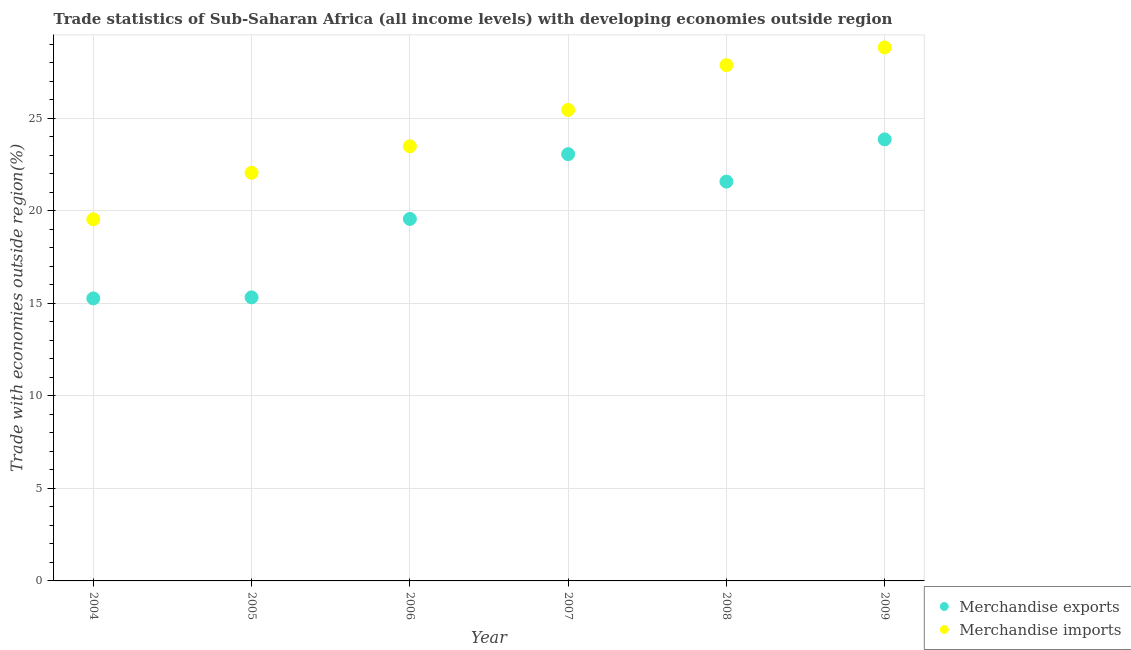How many different coloured dotlines are there?
Provide a succinct answer. 2. Is the number of dotlines equal to the number of legend labels?
Provide a short and direct response. Yes. What is the merchandise exports in 2006?
Offer a terse response. 19.56. Across all years, what is the maximum merchandise imports?
Your response must be concise. 28.83. Across all years, what is the minimum merchandise imports?
Keep it short and to the point. 19.54. In which year was the merchandise exports maximum?
Ensure brevity in your answer.  2009. In which year was the merchandise exports minimum?
Your answer should be compact. 2004. What is the total merchandise exports in the graph?
Make the answer very short. 118.64. What is the difference between the merchandise imports in 2006 and that in 2009?
Your answer should be very brief. -5.34. What is the difference between the merchandise exports in 2006 and the merchandise imports in 2008?
Offer a terse response. -8.31. What is the average merchandise imports per year?
Your response must be concise. 24.54. In the year 2008, what is the difference between the merchandise imports and merchandise exports?
Your response must be concise. 6.29. In how many years, is the merchandise imports greater than 22 %?
Offer a terse response. 5. What is the ratio of the merchandise exports in 2006 to that in 2009?
Provide a short and direct response. 0.82. Is the merchandise imports in 2004 less than that in 2005?
Your response must be concise. Yes. Is the difference between the merchandise exports in 2005 and 2009 greater than the difference between the merchandise imports in 2005 and 2009?
Provide a succinct answer. No. What is the difference between the highest and the second highest merchandise exports?
Provide a short and direct response. 0.8. What is the difference between the highest and the lowest merchandise imports?
Offer a very short reply. 9.28. In how many years, is the merchandise imports greater than the average merchandise imports taken over all years?
Keep it short and to the point. 3. Is the sum of the merchandise exports in 2008 and 2009 greater than the maximum merchandise imports across all years?
Make the answer very short. Yes. Is the merchandise exports strictly greater than the merchandise imports over the years?
Provide a short and direct response. No. How many dotlines are there?
Offer a terse response. 2. Does the graph contain grids?
Your answer should be compact. Yes. How many legend labels are there?
Offer a very short reply. 2. What is the title of the graph?
Keep it short and to the point. Trade statistics of Sub-Saharan Africa (all income levels) with developing economies outside region. Does "Merchandise imports" appear as one of the legend labels in the graph?
Ensure brevity in your answer.  Yes. What is the label or title of the Y-axis?
Keep it short and to the point. Trade with economies outside region(%). What is the Trade with economies outside region(%) in Merchandise exports in 2004?
Offer a very short reply. 15.27. What is the Trade with economies outside region(%) of Merchandise imports in 2004?
Your response must be concise. 19.54. What is the Trade with economies outside region(%) in Merchandise exports in 2005?
Provide a succinct answer. 15.32. What is the Trade with economies outside region(%) of Merchandise imports in 2005?
Offer a very short reply. 22.05. What is the Trade with economies outside region(%) of Merchandise exports in 2006?
Provide a succinct answer. 19.56. What is the Trade with economies outside region(%) in Merchandise imports in 2006?
Provide a succinct answer. 23.48. What is the Trade with economies outside region(%) of Merchandise exports in 2007?
Give a very brief answer. 23.06. What is the Trade with economies outside region(%) of Merchandise imports in 2007?
Offer a very short reply. 25.45. What is the Trade with economies outside region(%) of Merchandise exports in 2008?
Give a very brief answer. 21.58. What is the Trade with economies outside region(%) in Merchandise imports in 2008?
Offer a very short reply. 27.87. What is the Trade with economies outside region(%) of Merchandise exports in 2009?
Give a very brief answer. 23.86. What is the Trade with economies outside region(%) of Merchandise imports in 2009?
Offer a very short reply. 28.83. Across all years, what is the maximum Trade with economies outside region(%) in Merchandise exports?
Make the answer very short. 23.86. Across all years, what is the maximum Trade with economies outside region(%) in Merchandise imports?
Offer a terse response. 28.83. Across all years, what is the minimum Trade with economies outside region(%) of Merchandise exports?
Keep it short and to the point. 15.27. Across all years, what is the minimum Trade with economies outside region(%) of Merchandise imports?
Ensure brevity in your answer.  19.54. What is the total Trade with economies outside region(%) of Merchandise exports in the graph?
Your answer should be compact. 118.64. What is the total Trade with economies outside region(%) of Merchandise imports in the graph?
Offer a terse response. 147.22. What is the difference between the Trade with economies outside region(%) in Merchandise exports in 2004 and that in 2005?
Your answer should be very brief. -0.06. What is the difference between the Trade with economies outside region(%) of Merchandise imports in 2004 and that in 2005?
Provide a succinct answer. -2.51. What is the difference between the Trade with economies outside region(%) of Merchandise exports in 2004 and that in 2006?
Ensure brevity in your answer.  -4.29. What is the difference between the Trade with economies outside region(%) in Merchandise imports in 2004 and that in 2006?
Provide a succinct answer. -3.94. What is the difference between the Trade with economies outside region(%) of Merchandise exports in 2004 and that in 2007?
Your answer should be compact. -7.79. What is the difference between the Trade with economies outside region(%) of Merchandise imports in 2004 and that in 2007?
Offer a very short reply. -5.91. What is the difference between the Trade with economies outside region(%) in Merchandise exports in 2004 and that in 2008?
Provide a short and direct response. -6.31. What is the difference between the Trade with economies outside region(%) of Merchandise imports in 2004 and that in 2008?
Give a very brief answer. -8.33. What is the difference between the Trade with economies outside region(%) of Merchandise exports in 2004 and that in 2009?
Keep it short and to the point. -8.59. What is the difference between the Trade with economies outside region(%) of Merchandise imports in 2004 and that in 2009?
Offer a terse response. -9.29. What is the difference between the Trade with economies outside region(%) of Merchandise exports in 2005 and that in 2006?
Keep it short and to the point. -4.24. What is the difference between the Trade with economies outside region(%) in Merchandise imports in 2005 and that in 2006?
Your answer should be compact. -1.43. What is the difference between the Trade with economies outside region(%) in Merchandise exports in 2005 and that in 2007?
Make the answer very short. -7.74. What is the difference between the Trade with economies outside region(%) of Merchandise imports in 2005 and that in 2007?
Provide a short and direct response. -3.4. What is the difference between the Trade with economies outside region(%) of Merchandise exports in 2005 and that in 2008?
Provide a short and direct response. -6.25. What is the difference between the Trade with economies outside region(%) in Merchandise imports in 2005 and that in 2008?
Give a very brief answer. -5.82. What is the difference between the Trade with economies outside region(%) in Merchandise exports in 2005 and that in 2009?
Keep it short and to the point. -8.54. What is the difference between the Trade with economies outside region(%) of Merchandise imports in 2005 and that in 2009?
Your answer should be very brief. -6.77. What is the difference between the Trade with economies outside region(%) in Merchandise exports in 2006 and that in 2007?
Your answer should be compact. -3.5. What is the difference between the Trade with economies outside region(%) of Merchandise imports in 2006 and that in 2007?
Provide a short and direct response. -1.97. What is the difference between the Trade with economies outside region(%) in Merchandise exports in 2006 and that in 2008?
Provide a short and direct response. -2.02. What is the difference between the Trade with economies outside region(%) of Merchandise imports in 2006 and that in 2008?
Make the answer very short. -4.39. What is the difference between the Trade with economies outside region(%) in Merchandise exports in 2006 and that in 2009?
Ensure brevity in your answer.  -4.3. What is the difference between the Trade with economies outside region(%) of Merchandise imports in 2006 and that in 2009?
Give a very brief answer. -5.34. What is the difference between the Trade with economies outside region(%) in Merchandise exports in 2007 and that in 2008?
Offer a very short reply. 1.48. What is the difference between the Trade with economies outside region(%) in Merchandise imports in 2007 and that in 2008?
Provide a succinct answer. -2.42. What is the difference between the Trade with economies outside region(%) of Merchandise exports in 2007 and that in 2009?
Your response must be concise. -0.8. What is the difference between the Trade with economies outside region(%) of Merchandise imports in 2007 and that in 2009?
Keep it short and to the point. -3.38. What is the difference between the Trade with economies outside region(%) of Merchandise exports in 2008 and that in 2009?
Ensure brevity in your answer.  -2.28. What is the difference between the Trade with economies outside region(%) in Merchandise imports in 2008 and that in 2009?
Provide a succinct answer. -0.96. What is the difference between the Trade with economies outside region(%) of Merchandise exports in 2004 and the Trade with economies outside region(%) of Merchandise imports in 2005?
Ensure brevity in your answer.  -6.79. What is the difference between the Trade with economies outside region(%) in Merchandise exports in 2004 and the Trade with economies outside region(%) in Merchandise imports in 2006?
Ensure brevity in your answer.  -8.22. What is the difference between the Trade with economies outside region(%) in Merchandise exports in 2004 and the Trade with economies outside region(%) in Merchandise imports in 2007?
Your response must be concise. -10.18. What is the difference between the Trade with economies outside region(%) of Merchandise exports in 2004 and the Trade with economies outside region(%) of Merchandise imports in 2008?
Your answer should be very brief. -12.6. What is the difference between the Trade with economies outside region(%) of Merchandise exports in 2004 and the Trade with economies outside region(%) of Merchandise imports in 2009?
Offer a very short reply. -13.56. What is the difference between the Trade with economies outside region(%) of Merchandise exports in 2005 and the Trade with economies outside region(%) of Merchandise imports in 2006?
Keep it short and to the point. -8.16. What is the difference between the Trade with economies outside region(%) of Merchandise exports in 2005 and the Trade with economies outside region(%) of Merchandise imports in 2007?
Ensure brevity in your answer.  -10.13. What is the difference between the Trade with economies outside region(%) of Merchandise exports in 2005 and the Trade with economies outside region(%) of Merchandise imports in 2008?
Provide a short and direct response. -12.55. What is the difference between the Trade with economies outside region(%) of Merchandise exports in 2005 and the Trade with economies outside region(%) of Merchandise imports in 2009?
Keep it short and to the point. -13.5. What is the difference between the Trade with economies outside region(%) of Merchandise exports in 2006 and the Trade with economies outside region(%) of Merchandise imports in 2007?
Your response must be concise. -5.89. What is the difference between the Trade with economies outside region(%) in Merchandise exports in 2006 and the Trade with economies outside region(%) in Merchandise imports in 2008?
Make the answer very short. -8.31. What is the difference between the Trade with economies outside region(%) of Merchandise exports in 2006 and the Trade with economies outside region(%) of Merchandise imports in 2009?
Offer a terse response. -9.27. What is the difference between the Trade with economies outside region(%) of Merchandise exports in 2007 and the Trade with economies outside region(%) of Merchandise imports in 2008?
Give a very brief answer. -4.81. What is the difference between the Trade with economies outside region(%) in Merchandise exports in 2007 and the Trade with economies outside region(%) in Merchandise imports in 2009?
Your answer should be very brief. -5.77. What is the difference between the Trade with economies outside region(%) in Merchandise exports in 2008 and the Trade with economies outside region(%) in Merchandise imports in 2009?
Make the answer very short. -7.25. What is the average Trade with economies outside region(%) in Merchandise exports per year?
Offer a very short reply. 19.77. What is the average Trade with economies outside region(%) of Merchandise imports per year?
Ensure brevity in your answer.  24.54. In the year 2004, what is the difference between the Trade with economies outside region(%) of Merchandise exports and Trade with economies outside region(%) of Merchandise imports?
Provide a short and direct response. -4.28. In the year 2005, what is the difference between the Trade with economies outside region(%) in Merchandise exports and Trade with economies outside region(%) in Merchandise imports?
Your answer should be very brief. -6.73. In the year 2006, what is the difference between the Trade with economies outside region(%) in Merchandise exports and Trade with economies outside region(%) in Merchandise imports?
Your answer should be compact. -3.92. In the year 2007, what is the difference between the Trade with economies outside region(%) of Merchandise exports and Trade with economies outside region(%) of Merchandise imports?
Your response must be concise. -2.39. In the year 2008, what is the difference between the Trade with economies outside region(%) in Merchandise exports and Trade with economies outside region(%) in Merchandise imports?
Provide a succinct answer. -6.29. In the year 2009, what is the difference between the Trade with economies outside region(%) of Merchandise exports and Trade with economies outside region(%) of Merchandise imports?
Provide a succinct answer. -4.97. What is the ratio of the Trade with economies outside region(%) in Merchandise imports in 2004 to that in 2005?
Provide a short and direct response. 0.89. What is the ratio of the Trade with economies outside region(%) in Merchandise exports in 2004 to that in 2006?
Offer a very short reply. 0.78. What is the ratio of the Trade with economies outside region(%) of Merchandise imports in 2004 to that in 2006?
Give a very brief answer. 0.83. What is the ratio of the Trade with economies outside region(%) of Merchandise exports in 2004 to that in 2007?
Your answer should be compact. 0.66. What is the ratio of the Trade with economies outside region(%) in Merchandise imports in 2004 to that in 2007?
Your answer should be very brief. 0.77. What is the ratio of the Trade with economies outside region(%) of Merchandise exports in 2004 to that in 2008?
Keep it short and to the point. 0.71. What is the ratio of the Trade with economies outside region(%) of Merchandise imports in 2004 to that in 2008?
Your response must be concise. 0.7. What is the ratio of the Trade with economies outside region(%) of Merchandise exports in 2004 to that in 2009?
Provide a short and direct response. 0.64. What is the ratio of the Trade with economies outside region(%) in Merchandise imports in 2004 to that in 2009?
Make the answer very short. 0.68. What is the ratio of the Trade with economies outside region(%) in Merchandise exports in 2005 to that in 2006?
Ensure brevity in your answer.  0.78. What is the ratio of the Trade with economies outside region(%) of Merchandise imports in 2005 to that in 2006?
Give a very brief answer. 0.94. What is the ratio of the Trade with economies outside region(%) in Merchandise exports in 2005 to that in 2007?
Keep it short and to the point. 0.66. What is the ratio of the Trade with economies outside region(%) in Merchandise imports in 2005 to that in 2007?
Your answer should be compact. 0.87. What is the ratio of the Trade with economies outside region(%) in Merchandise exports in 2005 to that in 2008?
Provide a succinct answer. 0.71. What is the ratio of the Trade with economies outside region(%) of Merchandise imports in 2005 to that in 2008?
Ensure brevity in your answer.  0.79. What is the ratio of the Trade with economies outside region(%) of Merchandise exports in 2005 to that in 2009?
Your answer should be very brief. 0.64. What is the ratio of the Trade with economies outside region(%) in Merchandise imports in 2005 to that in 2009?
Give a very brief answer. 0.77. What is the ratio of the Trade with economies outside region(%) of Merchandise exports in 2006 to that in 2007?
Provide a succinct answer. 0.85. What is the ratio of the Trade with economies outside region(%) of Merchandise imports in 2006 to that in 2007?
Offer a terse response. 0.92. What is the ratio of the Trade with economies outside region(%) in Merchandise exports in 2006 to that in 2008?
Provide a succinct answer. 0.91. What is the ratio of the Trade with economies outside region(%) in Merchandise imports in 2006 to that in 2008?
Keep it short and to the point. 0.84. What is the ratio of the Trade with economies outside region(%) of Merchandise exports in 2006 to that in 2009?
Keep it short and to the point. 0.82. What is the ratio of the Trade with economies outside region(%) of Merchandise imports in 2006 to that in 2009?
Make the answer very short. 0.81. What is the ratio of the Trade with economies outside region(%) of Merchandise exports in 2007 to that in 2008?
Offer a terse response. 1.07. What is the ratio of the Trade with economies outside region(%) of Merchandise imports in 2007 to that in 2008?
Offer a very short reply. 0.91. What is the ratio of the Trade with economies outside region(%) of Merchandise exports in 2007 to that in 2009?
Offer a very short reply. 0.97. What is the ratio of the Trade with economies outside region(%) of Merchandise imports in 2007 to that in 2009?
Offer a very short reply. 0.88. What is the ratio of the Trade with economies outside region(%) in Merchandise exports in 2008 to that in 2009?
Keep it short and to the point. 0.9. What is the ratio of the Trade with economies outside region(%) in Merchandise imports in 2008 to that in 2009?
Keep it short and to the point. 0.97. What is the difference between the highest and the second highest Trade with economies outside region(%) in Merchandise exports?
Provide a succinct answer. 0.8. What is the difference between the highest and the second highest Trade with economies outside region(%) in Merchandise imports?
Your answer should be very brief. 0.96. What is the difference between the highest and the lowest Trade with economies outside region(%) of Merchandise exports?
Offer a terse response. 8.59. What is the difference between the highest and the lowest Trade with economies outside region(%) of Merchandise imports?
Provide a succinct answer. 9.29. 